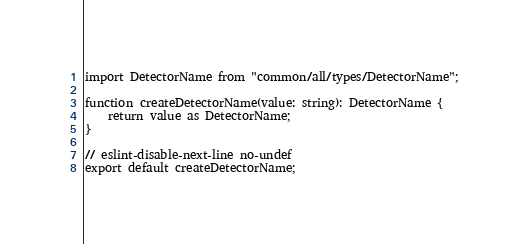Convert code to text. <code><loc_0><loc_0><loc_500><loc_500><_TypeScript_>import DetectorName from "common/all/types/DetectorName";

function createDetectorName(value: string): DetectorName {
	return value as DetectorName;
}

// eslint-disable-next-line no-undef
export default createDetectorName;
</code> 